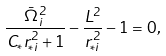<formula> <loc_0><loc_0><loc_500><loc_500>\frac { \bar { \Omega } ^ { 2 } _ { i } } { C _ { * } r ^ { 2 } _ { * i } + 1 } - \frac { L ^ { 2 } } { r _ { * i } ^ { 2 } } - 1 = 0 ,</formula> 